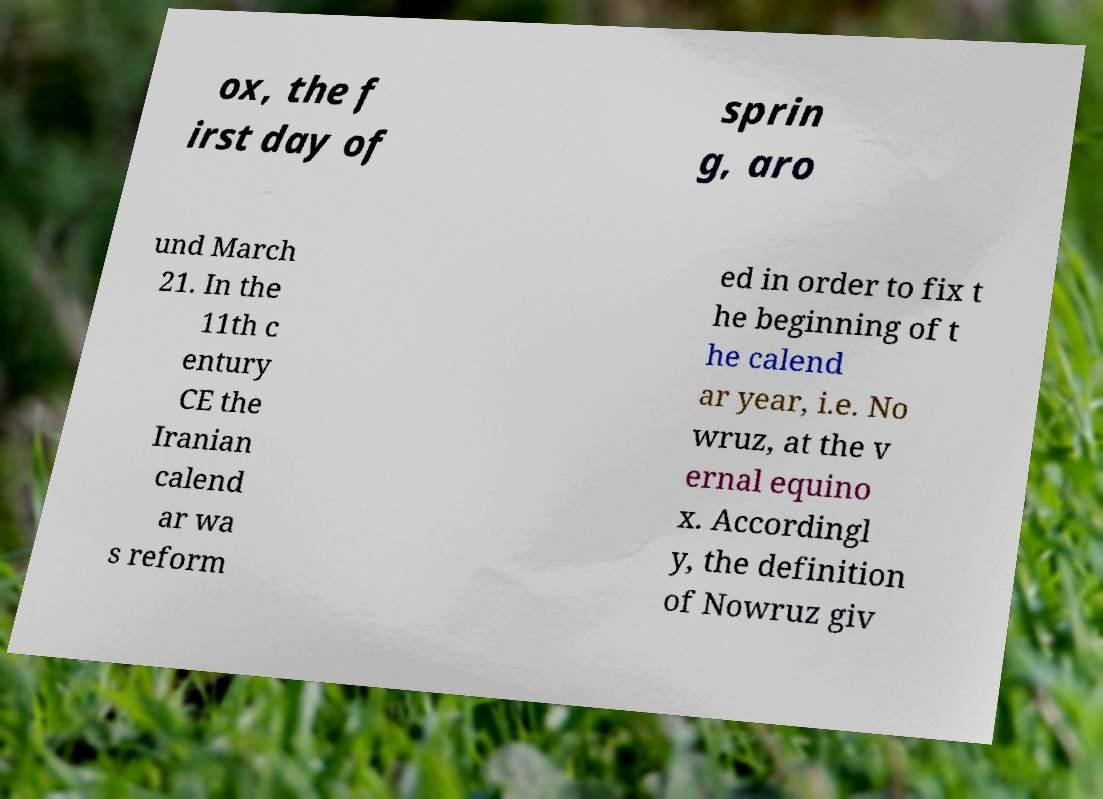Could you assist in decoding the text presented in this image and type it out clearly? ox, the f irst day of sprin g, aro und March 21. In the 11th c entury CE the Iranian calend ar wa s reform ed in order to fix t he beginning of t he calend ar year, i.e. No wruz, at the v ernal equino x. Accordingl y, the definition of Nowruz giv 